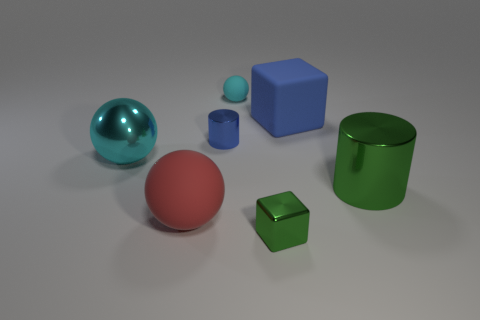Is the number of large blue cubes in front of the red ball greater than the number of large cyan metal things?
Offer a very short reply. No. There is a cyan object behind the large cyan shiny sphere; is it the same shape as the big cyan object?
Offer a very short reply. Yes. What number of green things are either big spheres or large metal things?
Keep it short and to the point. 1. Are there more large cyan metal objects than green objects?
Your response must be concise. No. The shiny cylinder that is the same size as the blue rubber cube is what color?
Make the answer very short. Green. What number of spheres are tiny rubber things or red things?
Provide a short and direct response. 2. Is the shape of the large cyan thing the same as the small cyan object behind the small green metallic thing?
Your answer should be compact. Yes. What number of blue cylinders have the same size as the blue block?
Give a very brief answer. 0. There is a large metal thing left of the tiny blue shiny object; is its shape the same as the shiny thing that is behind the large metal ball?
Provide a succinct answer. No. What is the shape of the big thing that is the same color as the tiny metal cylinder?
Provide a short and direct response. Cube. 